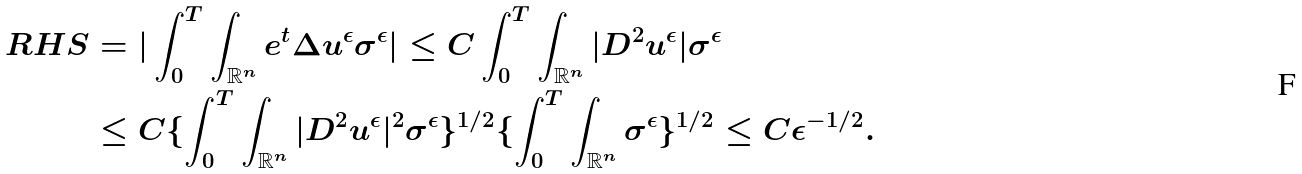Convert formula to latex. <formula><loc_0><loc_0><loc_500><loc_500>R H S & = | \int _ { 0 } ^ { T } \int _ { \mathbb { R } ^ { n } } e ^ { t } \Delta u ^ { \epsilon } \sigma ^ { \epsilon } | \leq C \int _ { 0 } ^ { T } \int _ { \mathbb { R } ^ { n } } | D ^ { 2 } u ^ { \epsilon } | \sigma ^ { \epsilon } \quad \\ & \leq C \{ \int _ { 0 } ^ { T } \int _ { \mathbb { R } ^ { n } } | D ^ { 2 } u ^ { \epsilon } | ^ { 2 } \sigma ^ { \epsilon } \} ^ { 1 / 2 } \{ \int _ { 0 } ^ { T } \int _ { \mathbb { R } ^ { n } } \sigma ^ { \epsilon } \} ^ { 1 / 2 } \leq C { \epsilon } ^ { - 1 / 2 } . \quad</formula> 